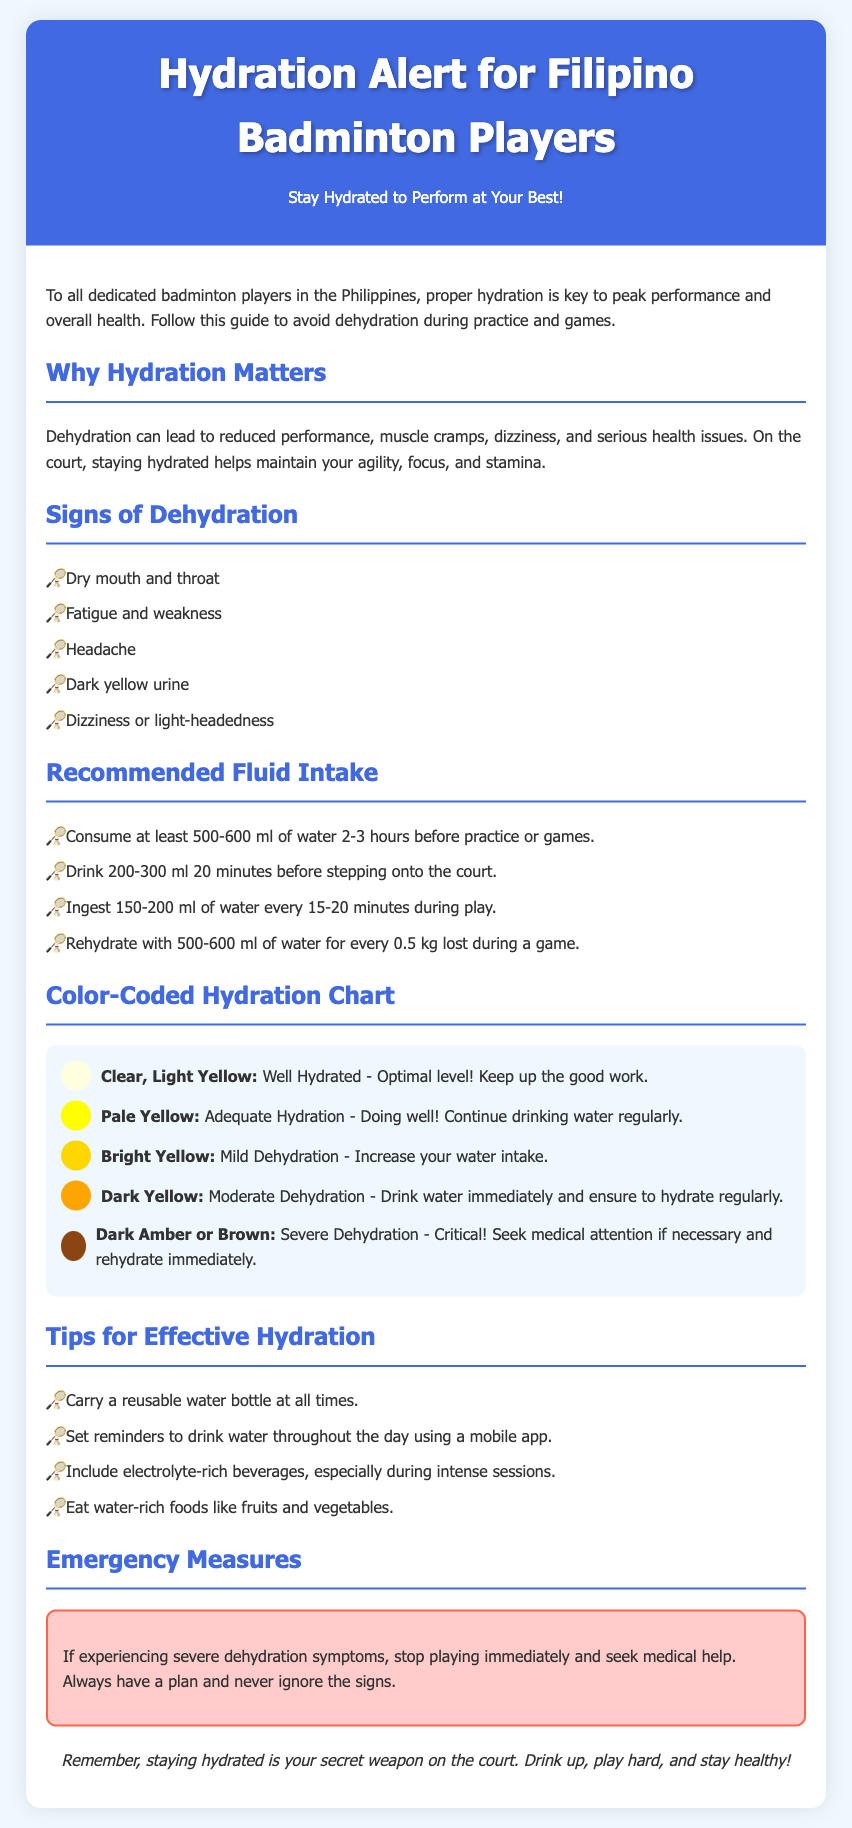What is the optimal hydration level? The document states that clear, light yellow urine indicates this hydration level.
Answer: Clear, Light Yellow How much water should be consumed 2-3 hours before practice? The document specifies that at least 500-600 ml of water should be consumed during this time.
Answer: 500-600 ml What color indicates severe dehydration? According to the hydration chart in the document, dark amber or brown indicates this severity.
Answer: Dark Amber or Brown What hydration level corresponds to mild dehydration? The document mentions that bright yellow urine signifies this level of dehydration.
Answer: Bright Yellow What should players do if they experience severe dehydration symptoms? The document advises stopping play and seeking medical help in such cases.
Answer: Seek medical help How frequently should water be ingested during play? The document recommends drinking 150-200 ml of water every 15-20 minutes during play.
Answer: 150-200 ml What should be included during intense sessions for hydration? The document suggests including electrolyte-rich beverages during these times.
Answer: Electrolyte-rich beverages What should players carry at all times for hydration? The document states that players should carry a reusable water bottle to stay hydrated.
Answer: Reusable water bottle 